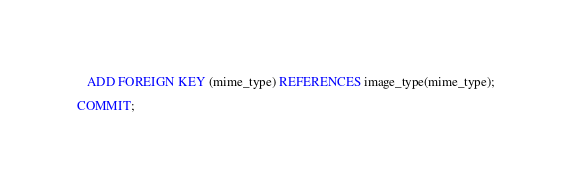Convert code to text. <code><loc_0><loc_0><loc_500><loc_500><_SQL_>   ADD FOREIGN KEY (mime_type) REFERENCES image_type(mime_type);

COMMIT;
</code> 